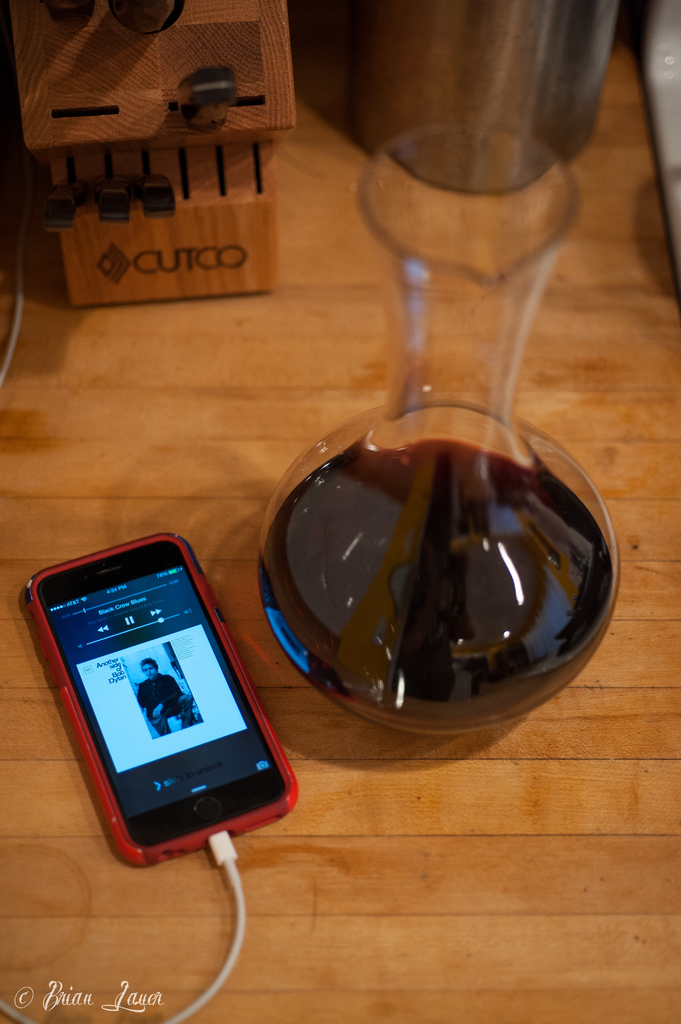Can you describe the function of the object behind the iPhone? The object behind the iPhone is a knife holder, specifically from the CUTCO brand, used for storing various kitchen knives securely. 